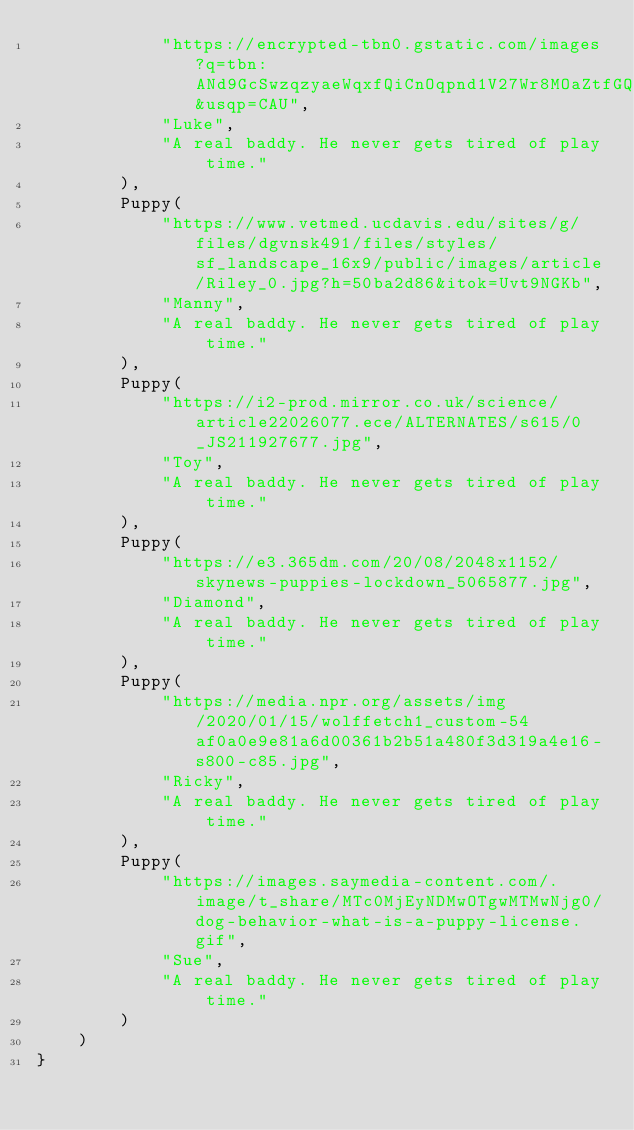<code> <loc_0><loc_0><loc_500><loc_500><_Kotlin_>            "https://encrypted-tbn0.gstatic.com/images?q=tbn:ANd9GcSwzqzyaeWqxfQiCnOqpnd1V27Wr8MOaZtfGQ&usqp=CAU",
            "Luke",
            "A real baddy. He never gets tired of play time."
        ),
        Puppy(
            "https://www.vetmed.ucdavis.edu/sites/g/files/dgvnsk491/files/styles/sf_landscape_16x9/public/images/article/Riley_0.jpg?h=50ba2d86&itok=Uvt9NGKb",
            "Manny",
            "A real baddy. He never gets tired of play time."
        ),
        Puppy(
            "https://i2-prod.mirror.co.uk/science/article22026077.ece/ALTERNATES/s615/0_JS211927677.jpg",
            "Toy",
            "A real baddy. He never gets tired of play time."
        ),
        Puppy(
            "https://e3.365dm.com/20/08/2048x1152/skynews-puppies-lockdown_5065877.jpg",
            "Diamond",
            "A real baddy. He never gets tired of play time."
        ),
        Puppy(
            "https://media.npr.org/assets/img/2020/01/15/wolffetch1_custom-54af0a0e9e81a6d00361b2b51a480f3d319a4e16-s800-c85.jpg",
            "Ricky",
            "A real baddy. He never gets tired of play time."
        ),
        Puppy(
            "https://images.saymedia-content.com/.image/t_share/MTc0MjEyNDMwOTgwMTMwNjg0/dog-behavior-what-is-a-puppy-license.gif",
            "Sue",
            "A real baddy. He never gets tired of play time."
        )
    )
}
</code> 